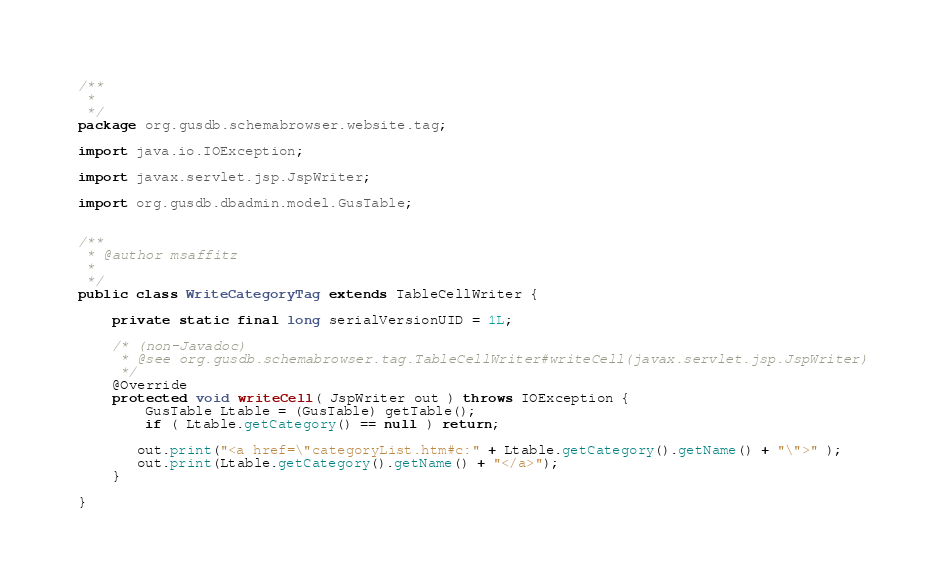<code> <loc_0><loc_0><loc_500><loc_500><_Java_>/**
 * 
 */
package org.gusdb.schemabrowser.website.tag;

import java.io.IOException;

import javax.servlet.jsp.JspWriter;

import org.gusdb.dbadmin.model.GusTable;


/**
 * @author msaffitz
 *
 */
public class WriteCategoryTag extends TableCellWriter {

    private static final long serialVersionUID = 1L;

    /* (non-Javadoc)
     * @see org.gusdb.schemabrowser.tag.TableCellWriter#writeCell(javax.servlet.jsp.JspWriter)
     */
    @Override
    protected void writeCell( JspWriter out ) throws IOException {
        GusTable Ltable = (GusTable) getTable();
        if ( Ltable.getCategory() == null ) return;
       
       out.print("<a href=\"categoryList.htm#c:" + Ltable.getCategory().getName() + "\">" );
       out.print(Ltable.getCategory().getName() + "</a>");
    }

}
</code> 